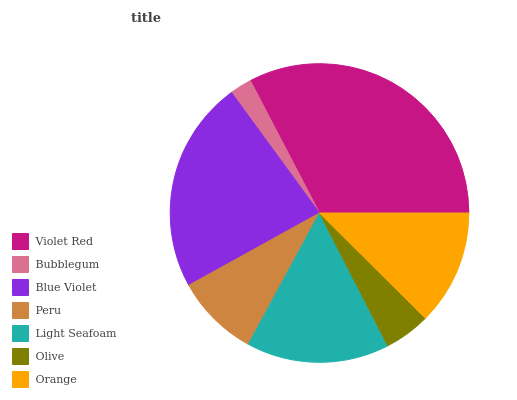Is Bubblegum the minimum?
Answer yes or no. Yes. Is Violet Red the maximum?
Answer yes or no. Yes. Is Blue Violet the minimum?
Answer yes or no. No. Is Blue Violet the maximum?
Answer yes or no. No. Is Blue Violet greater than Bubblegum?
Answer yes or no. Yes. Is Bubblegum less than Blue Violet?
Answer yes or no. Yes. Is Bubblegum greater than Blue Violet?
Answer yes or no. No. Is Blue Violet less than Bubblegum?
Answer yes or no. No. Is Orange the high median?
Answer yes or no. Yes. Is Orange the low median?
Answer yes or no. Yes. Is Olive the high median?
Answer yes or no. No. Is Olive the low median?
Answer yes or no. No. 